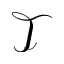Convert formula to latex. <formula><loc_0><loc_0><loc_500><loc_500>\mathcal { T }</formula> 